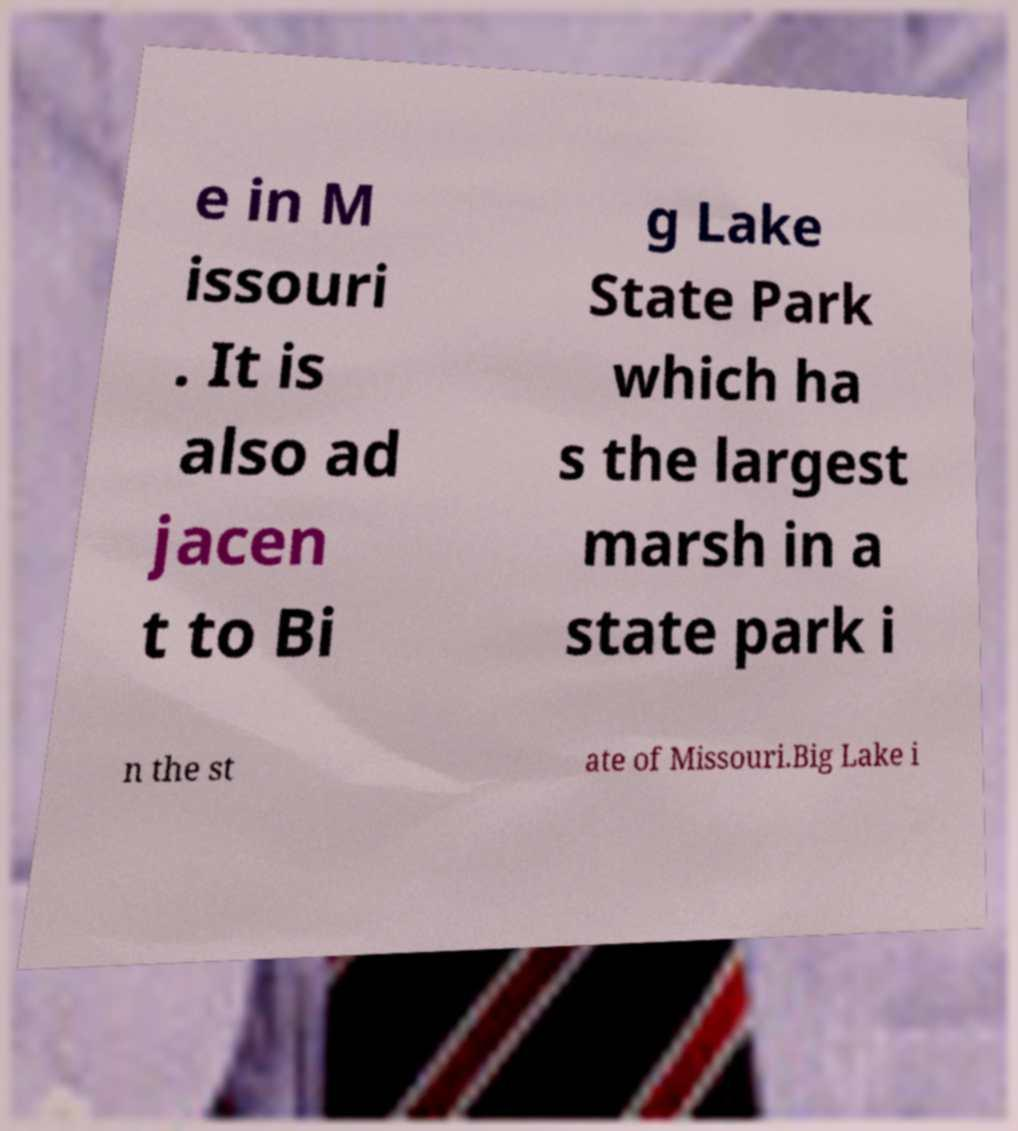Could you assist in decoding the text presented in this image and type it out clearly? e in M issouri . It is also ad jacen t to Bi g Lake State Park which ha s the largest marsh in a state park i n the st ate of Missouri.Big Lake i 